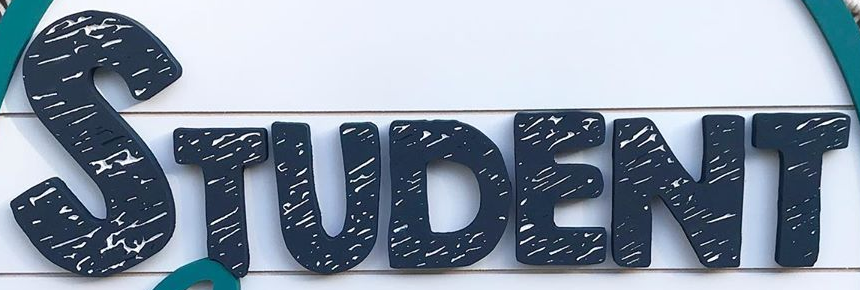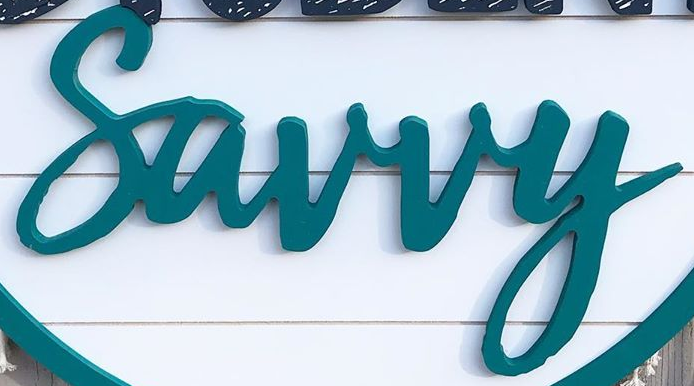What text appears in these images from left to right, separated by a semicolon? STUDENT; Surry 